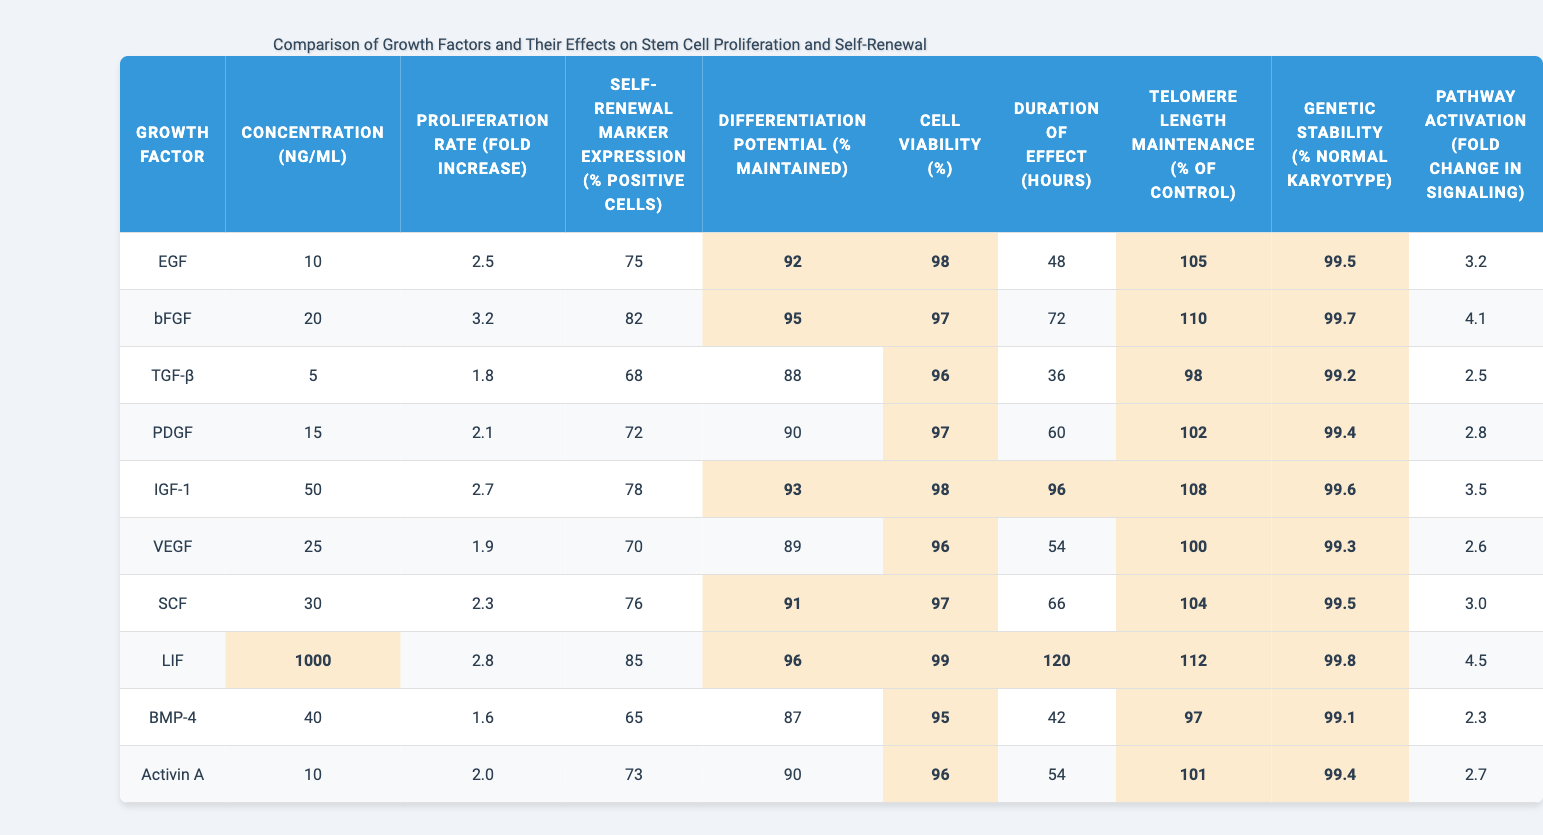What is the proliferation rate of bFGF? The table lists the proliferation rate for bFGF under the "Proliferation Rate (fold increase)" column, where the value is 3.2.
Answer: 3.2 Which growth factor has the highest self-renewal marker expression? By comparing the percentages in the "Self-Renewal Marker Expression (% positive cells)" column, LIF has the highest expression at 85%.
Answer: LIF What is the average duration of effect for all growth factors? To find the average, sum the values from the "Duration of Effect (hours)" column: (48 + 72 + 36 + 60 + 96 + 54 + 66 + 120 + 42 + 54) =  648, then divide by 10 (total growth factors) = 64.8 hours.
Answer: 64.8 hours Which growth factor has the lowest differentiation potential? Looking at the "Differentiation Potential (% maintained)" column, BMP-4 has the lowest value at 87%.
Answer: BMP-4 Is the cell viability for TGF-β greater than 95%? The value for TGF-β in the "Cell Viability (%)" column is 96%, which is greater than 95%.
Answer: Yes What is the difference in proliferation rate between IGF-1 and PDGF? To find the difference, we subtract the proliferation rates: IGF-1 is 2.7 and PDGF is 2.1, so the difference is 2.7 - 2.1 = 0.6.
Answer: 0.6 How many growth factors have a genetic stability of 99.6% or higher? By checking the "Genetic Stability (% normal karyotype)" column, the values of 99.5%, 99.7%, 99.6%, and 99.8% meet this criterion, totaling 6 growth factors.
Answer: 6 Which growth factor has the longest duration of effect, and how long is it? The "Duration of Effect (hours)" column indicates LIF has the longest duration, which is 120 hours.
Answer: LIF, 120 hours What is the average telomere length maintenance among all growth factors? Sum the values in the "Telomere Length Maintenance (% of control)" column: (105 + 110 + 98 + 102 + 108 + 100 + 104 + 112 + 97 + 101) = 1032, then divide by 10 for the average = 103.2%.
Answer: 103.2% Is the path activation for Activin A higher than that for VEGF? The "Pathway Activation (fold change in signaling)" for Activin A is 2.7 while VEGF is 2.6. Since 2.7 > 2.6, the statement is true.
Answer: Yes 